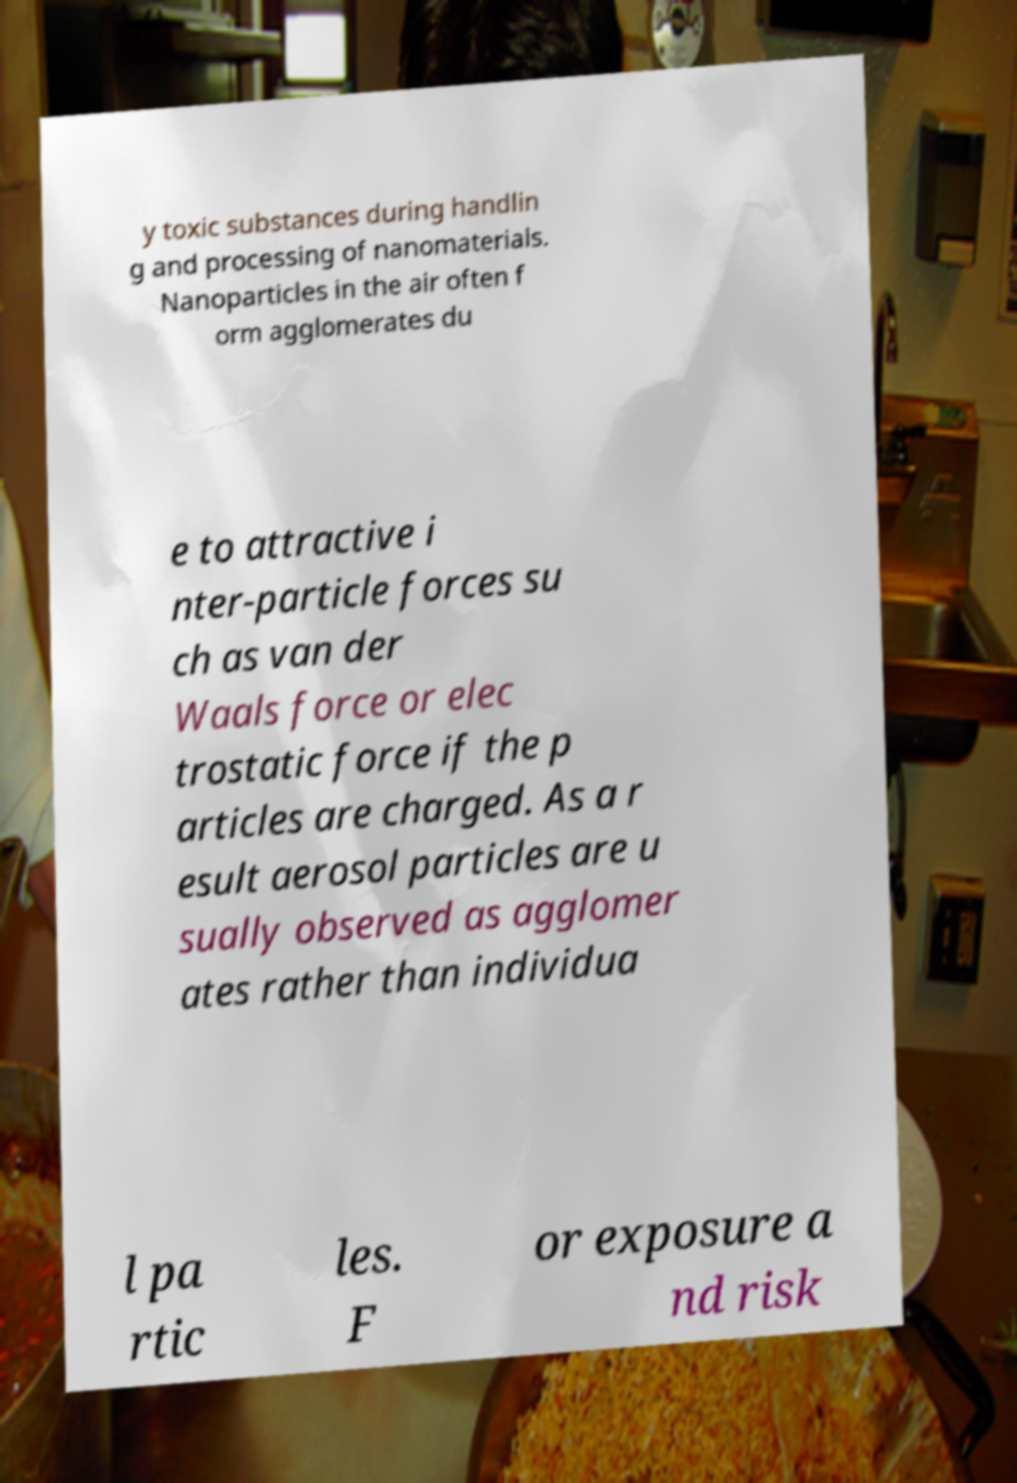What messages or text are displayed in this image? I need them in a readable, typed format. y toxic substances during handlin g and processing of nanomaterials. Nanoparticles in the air often f orm agglomerates du e to attractive i nter-particle forces su ch as van der Waals force or elec trostatic force if the p articles are charged. As a r esult aerosol particles are u sually observed as agglomer ates rather than individua l pa rtic les. F or exposure a nd risk 